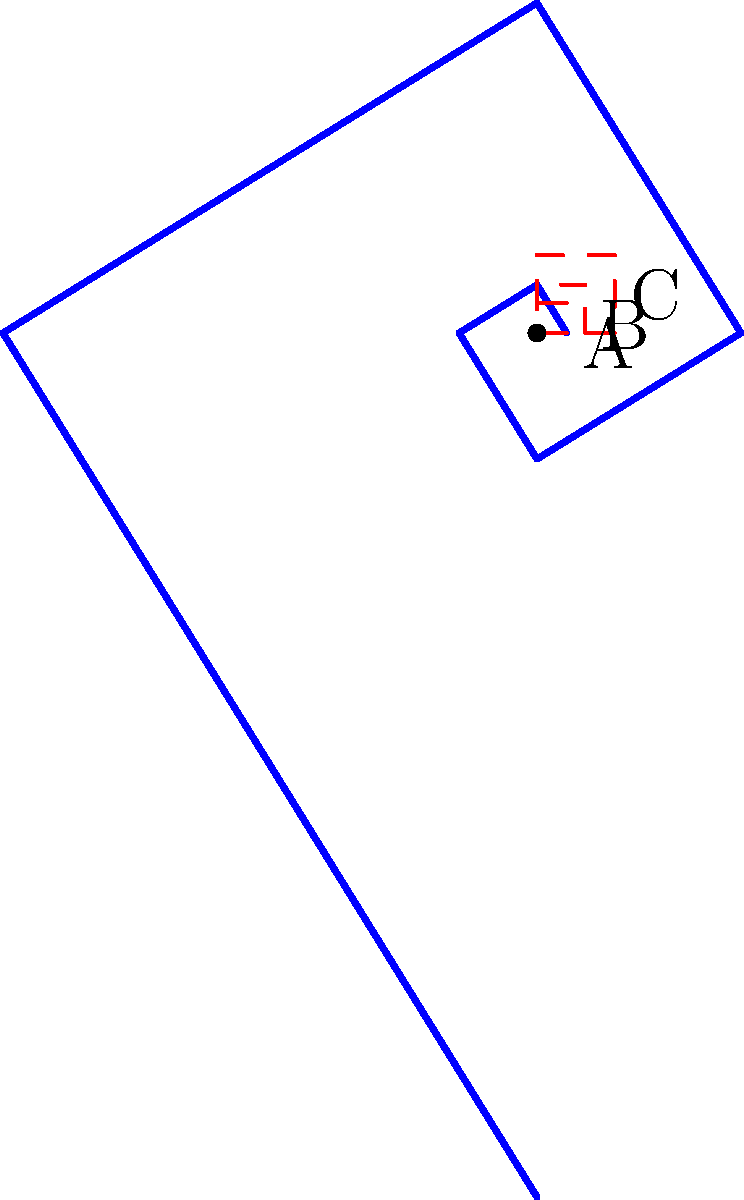In cinematography, the golden spiral is often used for composition. The diagram shows a golden spiral and three square frames (A, B, and C) that could represent different aspect ratios. If the side length of square A is 1 unit, what is the side length of square C? Express your answer in terms of $\phi$ (phi), the golden ratio. To solve this problem, let's follow these steps:

1) The golden ratio, $\phi$, is approximately 1.618.

2) In the golden spiral, each turn expands by a factor of $\phi$.

3) Square A has a side length of 1 unit.

4) To get from square A to square B, we multiply by $\phi$:
   Side length of B = $1 * \phi = \phi$

5) To get from square B to square C, we multiply by $\phi$ again:
   Side length of C = $\phi * \phi = \phi^2$

6) We can simplify $\phi^2$ using the property of the golden ratio:
   $\phi^2 = \phi + 1$

Therefore, the side length of square C is $\phi + 1$ units.
Answer: $\phi + 1$ 